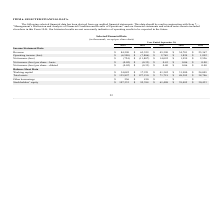According to Mitek Systems's financial document, What does the table show us? selected financial data has been derived from our audited financial statements. The document states: "The following selected financial data has been derived from our audited financial statements. This data should be read in conjunction with Item 7—..." Also, How should the table be read together with? Item 7— “Management’s Discussion and Analysis of Financial Condition and Results of Operations” and our financial statements and related notes thereto included elsewhere in this Form 10-K. The document states: "nts. This data should be read in conjunction with Item 7— “Management’s Discussion and Analysis of Financial Condition and Results of Operations” and ..." Also, How much were the revenues from 2015 to 2019 respectively? The document contains multiple relevant values: $25,367, $34,701, $45,390, $63,559, $84,590 (in thousands). From the document: "Income Statement Data Revenue $ 84,590 $ 63,559 $ 45,390 $ 34,701 $ 25,367 atement Data Revenue $ 84,590 $ 63,559 $ 45,390 $ 34,701 $ 25,367 Income St..." Also, can you calculate: What is the percentage change in working capital from 2018 to 2019? To answer this question, I need to perform calculations using the financial data. The calculation is: (34,082-17,221)/17,221 , which equals 97.91 (percentage). This is based on the information: "Balance Sheet Data Working capital $ 34,082 $ 17,221 $ 41,342 $ 31,980 $ 24,005 Balance Sheet Data Working capital $ 34,082 $ 17,221 $ 41,342 $ 31,980 $ 24,005..." The key data points involved are: 17,221, 34,082. Additionally, In which year did the company earn the highest net income? According to the financial document, 2017. The relevant text states: "2019 2018 2017 2016 2015..." Also, can you calculate: What is the average total assets for the last 5 years, i.e. 2015 to 2019? To answer this question, I need to perform calculations using the financial data. The calculation is: (135,897+127,150+71,719+48,385+38,746)/5 , which equals 84379.4 (in thousands). This is based on the information: "Total assets $ 135,897 $ 127,150 $ 71,719 $ 48,385 $ 38,746 Total assets $ 135,897 $ 127,150 $ 71,719 $ 48,385 $ 38,746 Total assets $ 135,897 $ 127,150 $ 71,719 $ 48,385 $ 38,746 Total assets $ 135,8..." The key data points involved are: 127,150, 135,897, 38,746. 